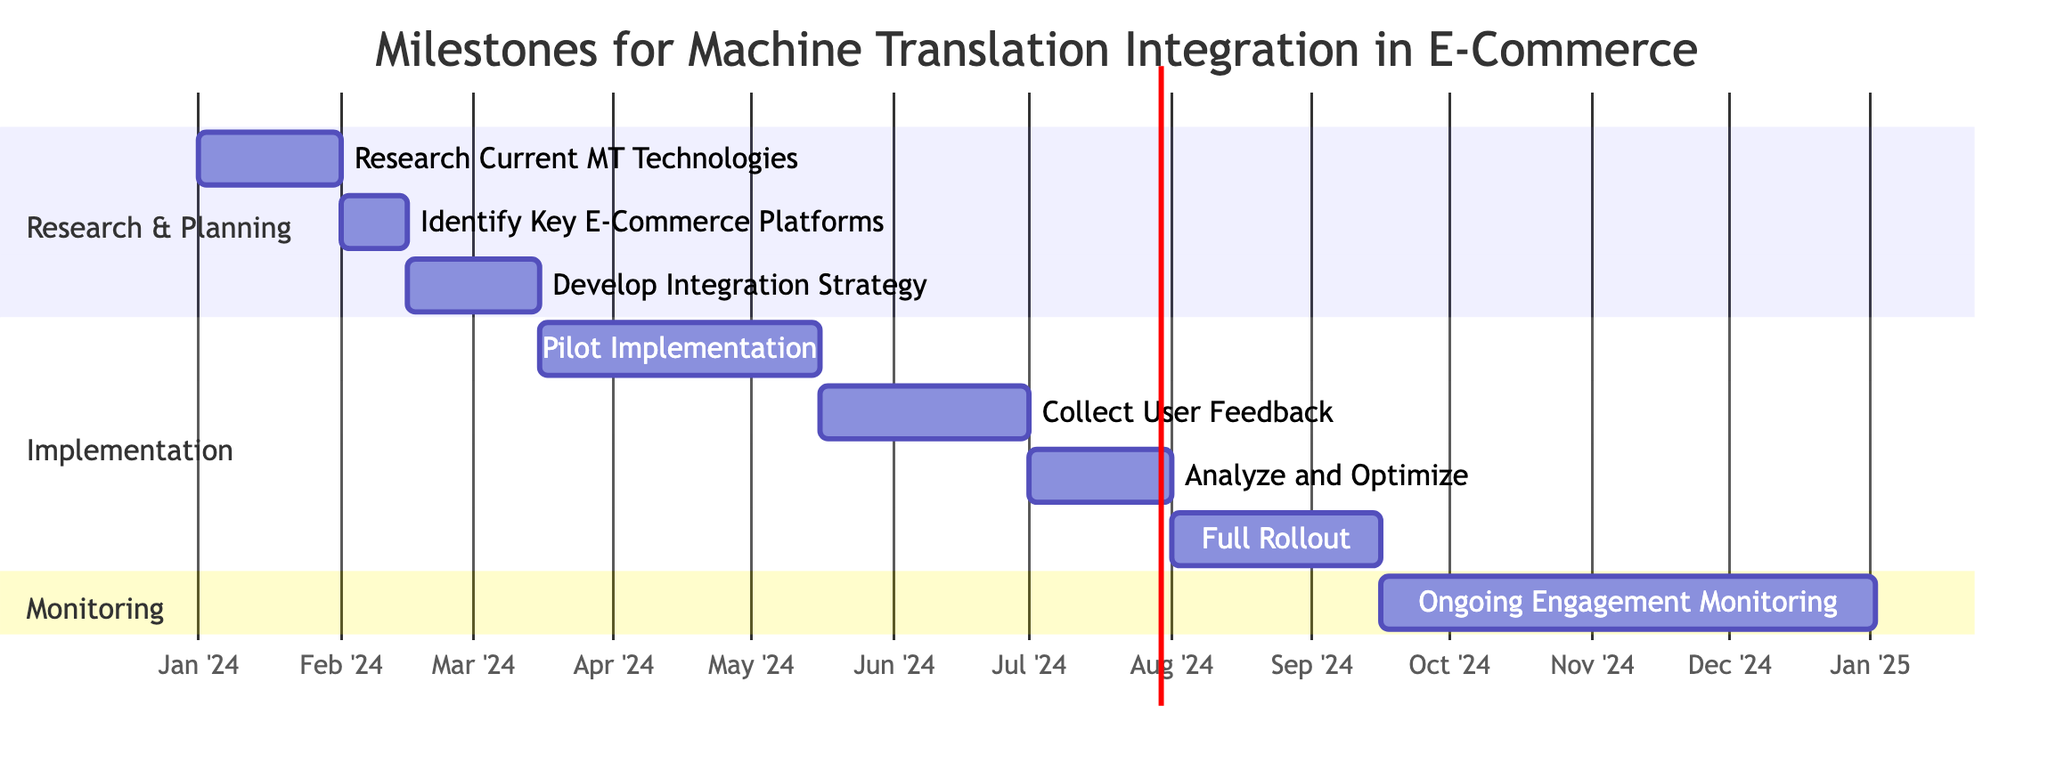What is the duration of the "Pilot Implementation" task? The "Pilot Implementation" task starts on March 16, 2024, and ends on May 15, 2024. By calculating the number of days from the start to the end date, it covers 61 days.
Answer: 61 days Which task follows "Analyze Feedback and Optimize Translation Engine"? The task that follows "Analyze Feedback and Optimize Translation Engine" is "Full Rollout of Machine Translation Features." This can be observed in the chronological flow of tasks in the Gantt chart.
Answer: Full Rollout of Machine Translation Features How many tasks are in the "Research & Planning" section? By reviewing the Gantt chart, there are three tasks listed under the "Research & Planning" section: "Research Current MT Technologies," "Identify Key E-Commerce Platforms for Integration," and "Develop Integration Strategy." Counting these, the total is three.
Answer: 3 What is the end date of the "Collect User Feedback and Engagement Metrics" task? The task "Collect User Feedback and Engagement Metrics" in the Gantt chart ends on June 30, 2024. This date is clearly marked at the end of the task bar in the chart.
Answer: June 30, 2024 Which section includes the longest task duration? Examining the task durations, the "Pilot Implementation" task lasts for 61 days, which is the longest duration compared to other tasks across all sections. Hence, the section that includes this longest task duration is "Implementation."
Answer: Implementation 